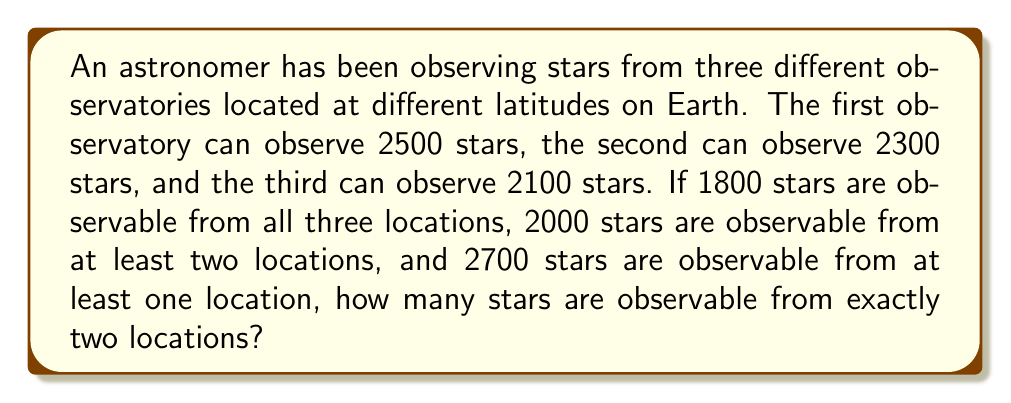Solve this math problem. Let's approach this problem using set theory:

1) Let $A$, $B$, and $C$ represent the sets of stars observable from each observatory.

2) Given information:
   $|A| = 2500$, $|B| = 2300$, $|C| = 2100$
   $|A \cap B \cap C| = 1800$
   $|A \cup B \cup C| = 2700$

3) Let's define:
   $x = $ number of stars observable from exactly two locations
   $y = $ number of stars observable from exactly one location

4) We know that stars observable from at least two locations = stars observable from all three + stars observable from exactly two:

   $2000 = 1800 + x$

5) We can also express the total number of observable stars using our variables:

   $2700 = 1800 + x + y$

6) From step 4, we can deduce:
   $x = 2000 - 1800 = 200$

7) We can verify this using the inclusion-exclusion principle:

   $|A \cup B \cup C| = |A| + |B| + |C| - |A \cap B| - |B \cap C| - |A \cap C| + |A \cap B \cap C|$

   $2700 = 2500 + 2300 + 2100 - (|A \cap B| + |B \cap C| + |A \cap C|) + 1800$

   $2700 = 6900 - (|A \cap B| + |B \cap C| + |A \cap C|) + 1800$

   $(|A \cap B| + |B \cap C| + |A \cap C|) = 6000$

   Since $|A \cap B \cap C| = 1800$, and $(|A \cap B| + |B \cap C| + |A \cap C|) = 6000$,
   the number of stars in exactly two sets is:

   $6000 - 3 * 1800 = 600$

   This confirms our result: 200 stars are observable from exactly two locations.
Answer: 200 stars are observable from exactly two locations. 